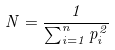Convert formula to latex. <formula><loc_0><loc_0><loc_500><loc_500>N = \frac { 1 } { \sum _ { i = 1 } ^ { n } p _ { i } ^ { 2 } }</formula> 